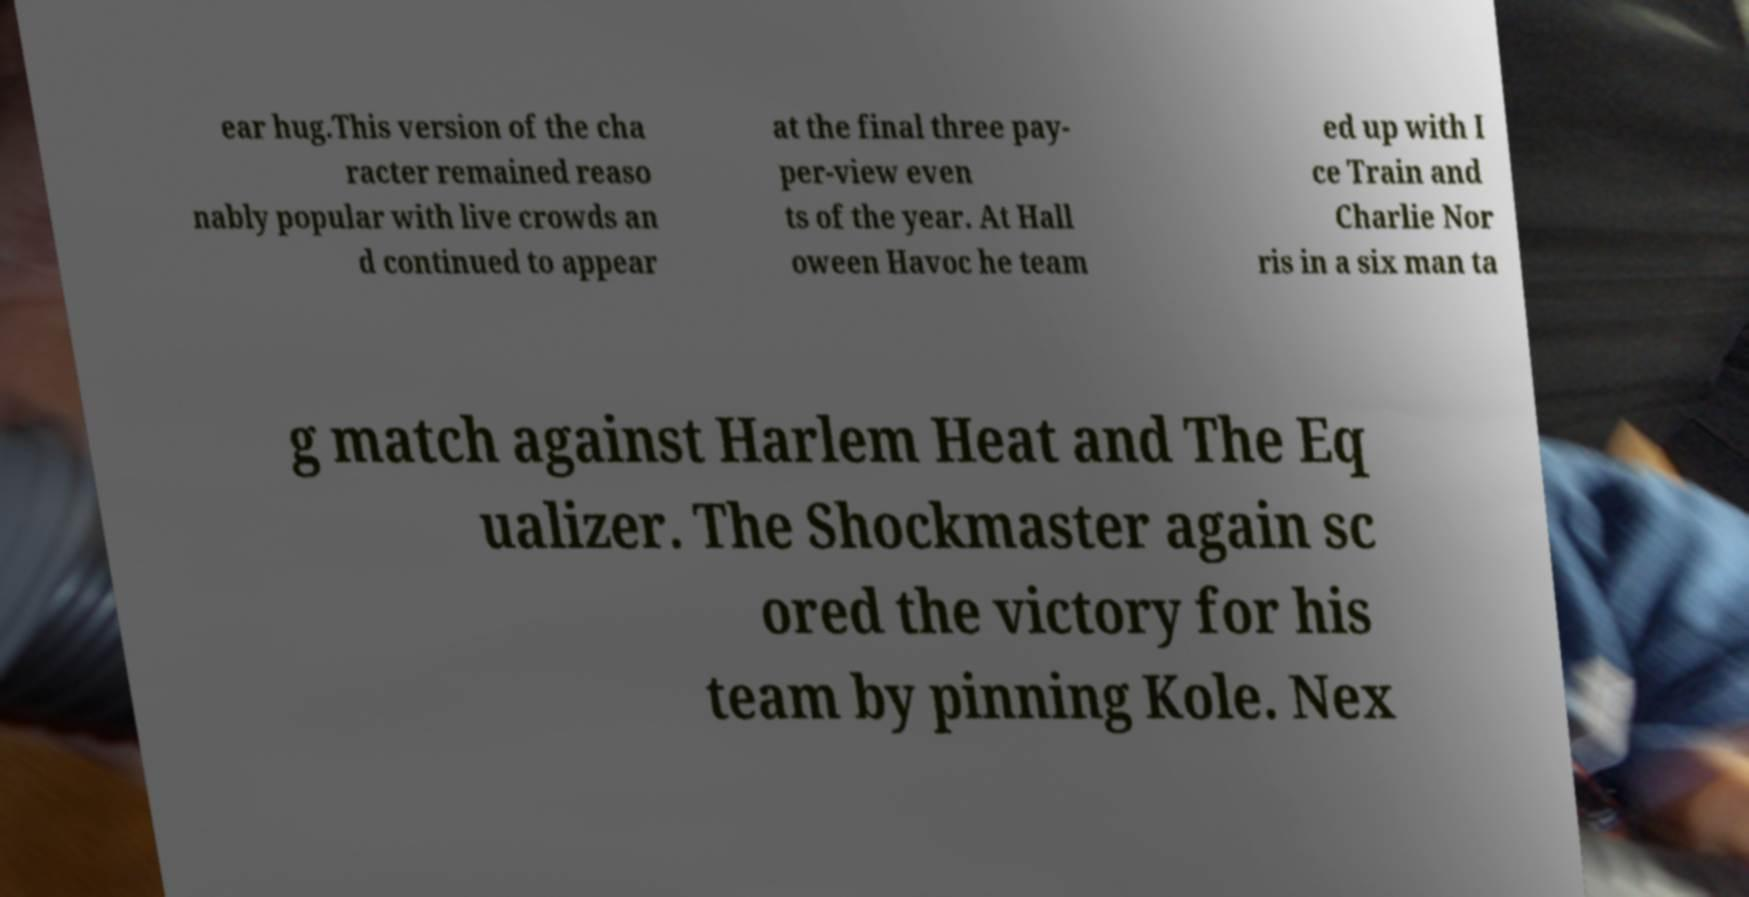What messages or text are displayed in this image? I need them in a readable, typed format. ear hug.This version of the cha racter remained reaso nably popular with live crowds an d continued to appear at the final three pay- per-view even ts of the year. At Hall oween Havoc he team ed up with I ce Train and Charlie Nor ris in a six man ta g match against Harlem Heat and The Eq ualizer. The Shockmaster again sc ored the victory for his team by pinning Kole. Nex 